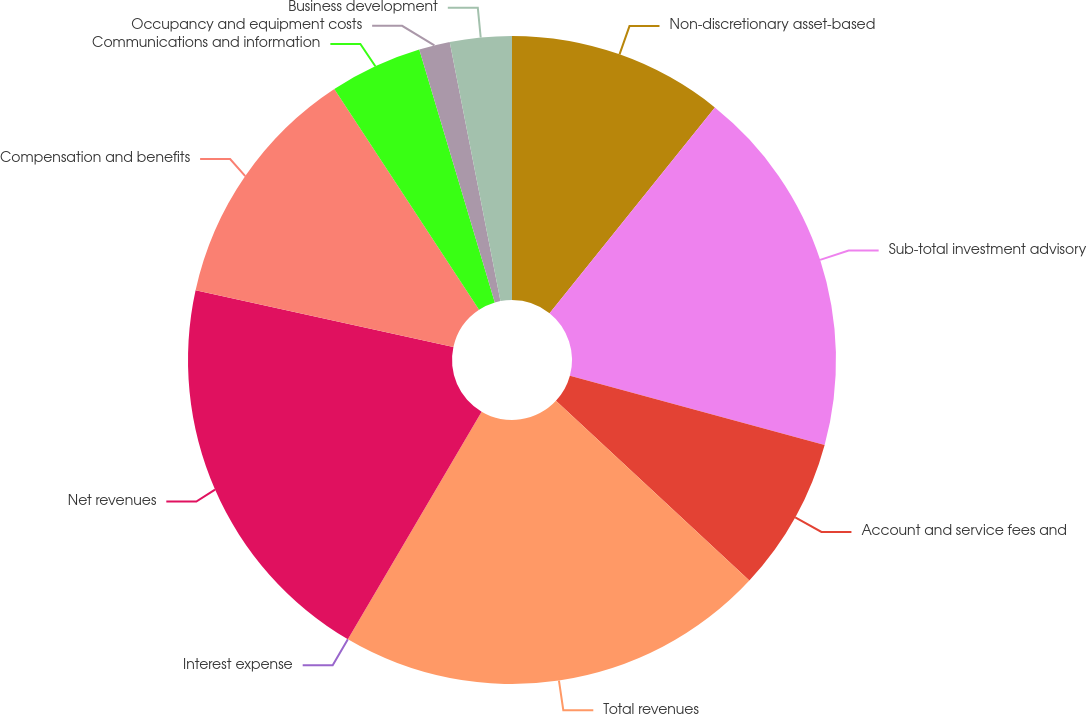Convert chart. <chart><loc_0><loc_0><loc_500><loc_500><pie_chart><fcel>Non-discretionary asset-based<fcel>Sub-total investment advisory<fcel>Account and service fees and<fcel>Total revenues<fcel>Interest expense<fcel>Net revenues<fcel>Compensation and benefits<fcel>Communications and information<fcel>Occupancy and equipment costs<fcel>Business development<nl><fcel>10.77%<fcel>18.46%<fcel>7.69%<fcel>21.54%<fcel>0.0%<fcel>20.0%<fcel>12.31%<fcel>4.62%<fcel>1.54%<fcel>3.08%<nl></chart> 